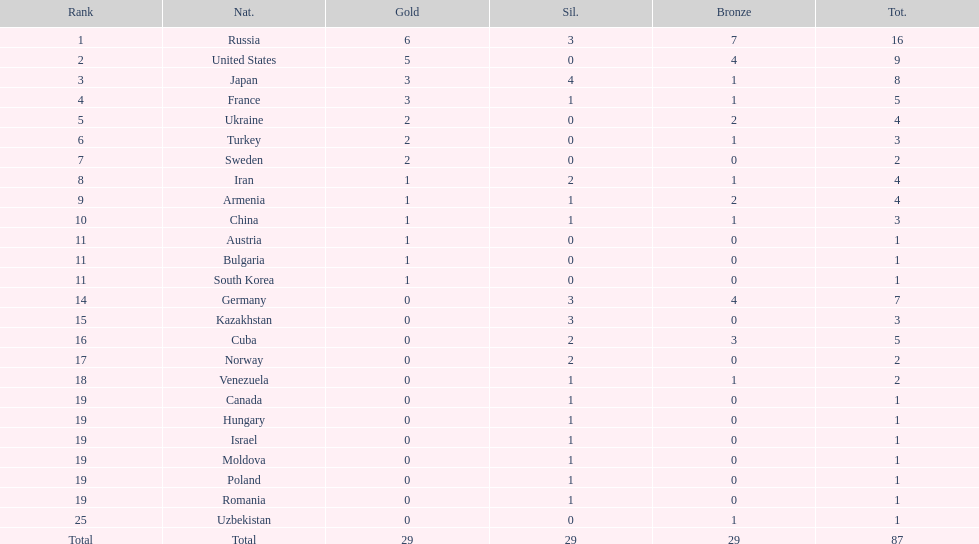How many silver medals did turkey win? 0. 